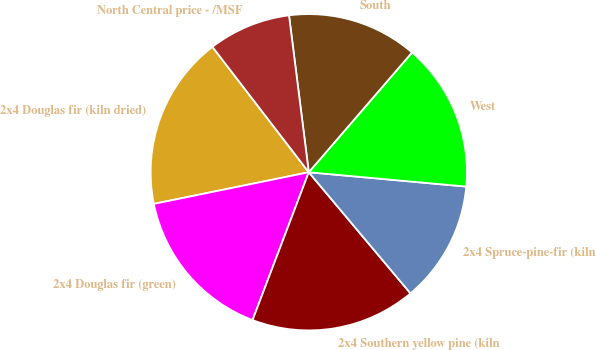Convert chart to OTSL. <chart><loc_0><loc_0><loc_500><loc_500><pie_chart><fcel>2x4 Douglas fir (kiln dried)<fcel>2x4 Douglas fir (green)<fcel>2x4 Southern yellow pine (kiln<fcel>2x4 Spruce-pine-fir (kiln<fcel>West<fcel>South<fcel>North Central price - /MSF<nl><fcel>17.78%<fcel>16.01%<fcel>16.9%<fcel>12.44%<fcel>15.12%<fcel>13.32%<fcel>8.43%<nl></chart> 